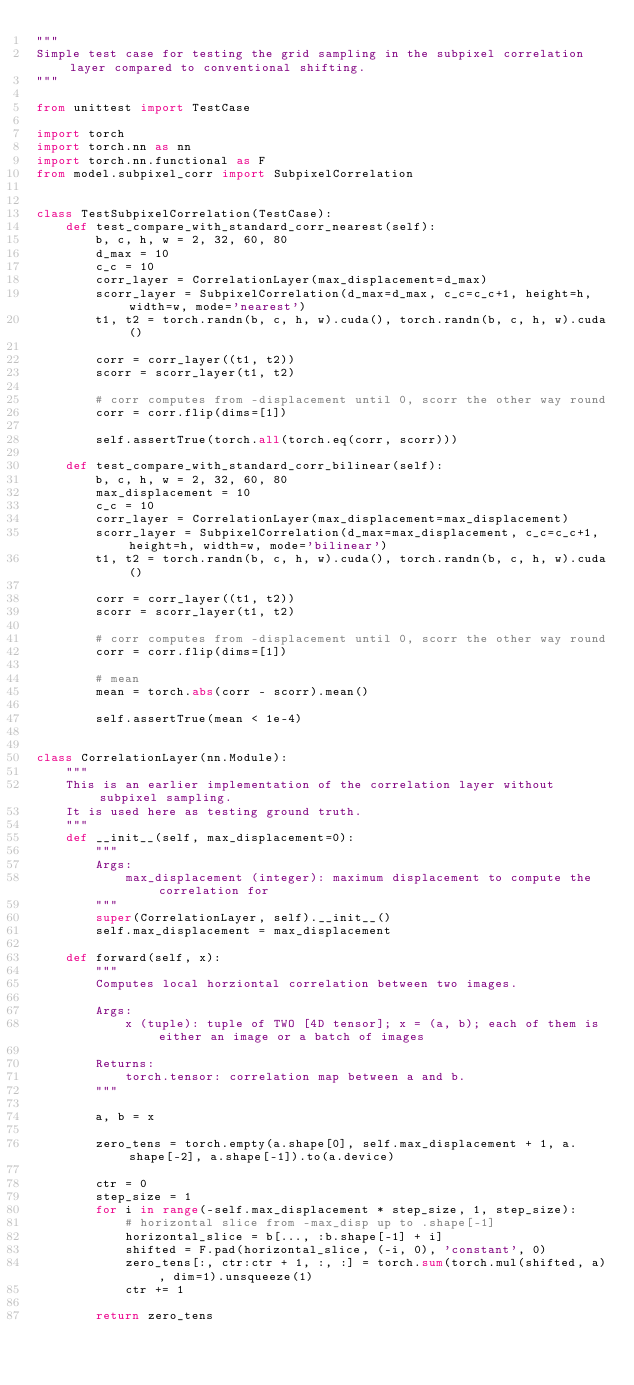<code> <loc_0><loc_0><loc_500><loc_500><_Python_>"""
Simple test case for testing the grid sampling in the subpixel correlation layer compared to conventional shifting.
"""

from unittest import TestCase

import torch
import torch.nn as nn
import torch.nn.functional as F
from model.subpixel_corr import SubpixelCorrelation


class TestSubpixelCorrelation(TestCase):
    def test_compare_with_standard_corr_nearest(self):
        b, c, h, w = 2, 32, 60, 80
        d_max = 10
        c_c = 10
        corr_layer = CorrelationLayer(max_displacement=d_max)
        scorr_layer = SubpixelCorrelation(d_max=d_max, c_c=c_c+1, height=h, width=w, mode='nearest')
        t1, t2 = torch.randn(b, c, h, w).cuda(), torch.randn(b, c, h, w).cuda()

        corr = corr_layer((t1, t2))
        scorr = scorr_layer(t1, t2)

        # corr computes from -displacement until 0, scorr the other way round
        corr = corr.flip(dims=[1])

        self.assertTrue(torch.all(torch.eq(corr, scorr)))

    def test_compare_with_standard_corr_bilinear(self):
        b, c, h, w = 2, 32, 60, 80
        max_displacement = 10
        c_c = 10
        corr_layer = CorrelationLayer(max_displacement=max_displacement)
        scorr_layer = SubpixelCorrelation(d_max=max_displacement, c_c=c_c+1, height=h, width=w, mode='bilinear')
        t1, t2 = torch.randn(b, c, h, w).cuda(), torch.randn(b, c, h, w).cuda()

        corr = corr_layer((t1, t2))
        scorr = scorr_layer(t1, t2)

        # corr computes from -displacement until 0, scorr the other way round
        corr = corr.flip(dims=[1])

        # mean
        mean = torch.abs(corr - scorr).mean()

        self.assertTrue(mean < 1e-4)


class CorrelationLayer(nn.Module):
    """
    This is an earlier implementation of the correlation layer without subpixel sampling.
    It is used here as testing ground truth.
    """
    def __init__(self, max_displacement=0):
        """
        Args:
            max_displacement (integer): maximum displacement to compute the correlation for
        """
        super(CorrelationLayer, self).__init__()
        self.max_displacement = max_displacement

    def forward(self, x):
        """
        Computes local horziontal correlation between two images.

        Args:
            x (tuple): tuple of TWO [4D tensor]; x = (a, b); each of them is either an image or a batch of images

        Returns:
            torch.tensor: correlation map between a and b.
        """

        a, b = x

        zero_tens = torch.empty(a.shape[0], self.max_displacement + 1, a.shape[-2], a.shape[-1]).to(a.device)

        ctr = 0
        step_size = 1
        for i in range(-self.max_displacement * step_size, 1, step_size):
            # horizontal slice from -max_disp up to .shape[-1]
            horizontal_slice = b[..., :b.shape[-1] + i]
            shifted = F.pad(horizontal_slice, (-i, 0), 'constant', 0)
            zero_tens[:, ctr:ctr + 1, :, :] = torch.sum(torch.mul(shifted, a), dim=1).unsqueeze(1)
            ctr += 1

        return zero_tens
</code> 